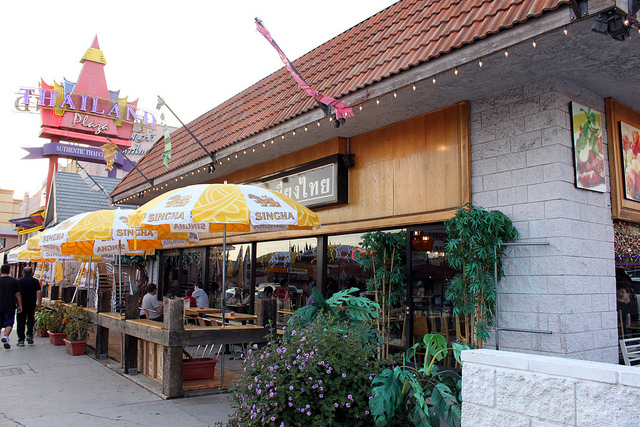Extract all visible text content from this image. THAILAND Plaza SINGHA SINGHA SINGHA SINGGHA SINGHA SINGHA AUTHENTIC 